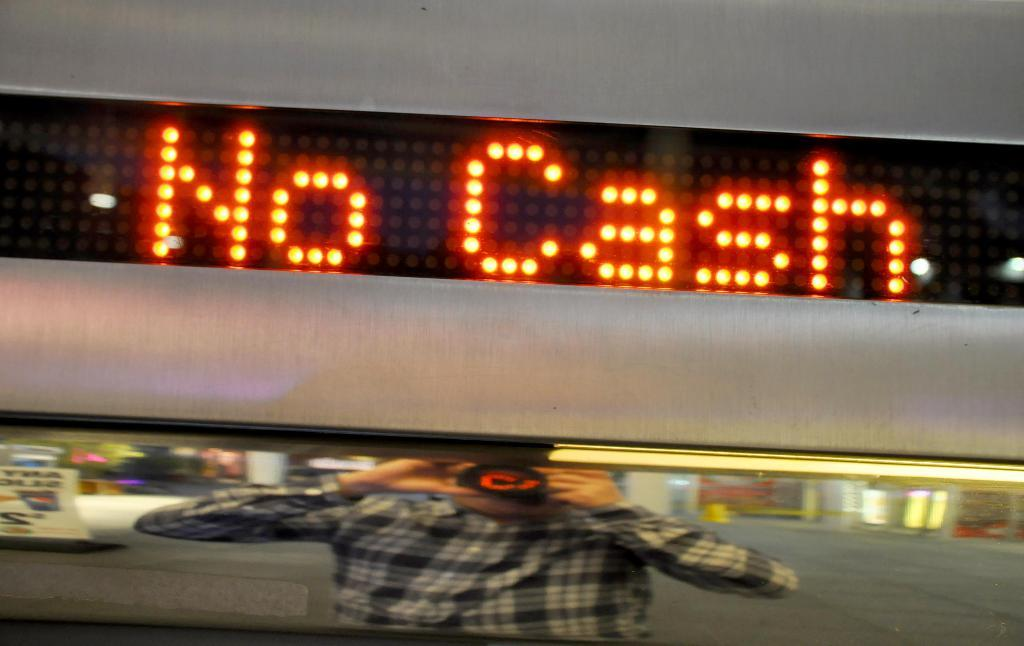<image>
Describe the image concisely. A large LED light that says "No Cash". 